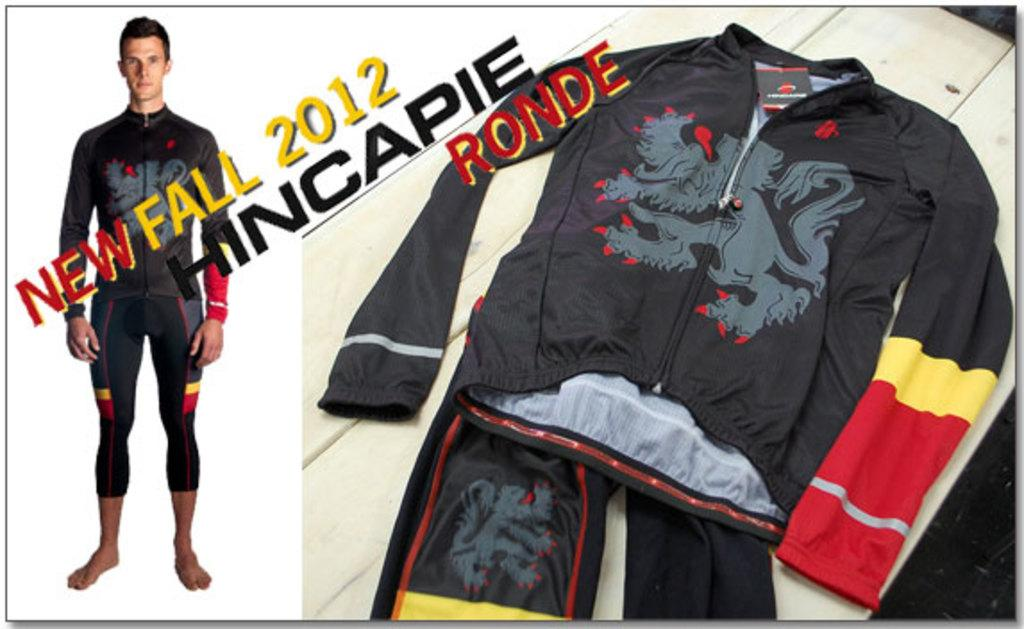What is placed on the table in the image? There is a dress placed on a table in the image. What is the person wearing in the image? The person is wearing a dress in the image. Where is the person standing in relation to the table? The person is standing next to the table in the image. What can be seen in addition to the dress and person? There is some text written in the image. What type of judge is present in the image? There is no judge present in the image. What is the name of the downtown area depicted in the image? The image does not depict a downtown area. How many people are in the group standing next to the table in the image? There is no group present in the image; only one person is standing next to the table. 